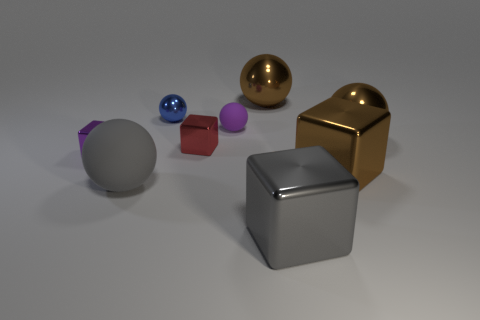Are there any other small red cubes made of the same material as the small red cube?
Your answer should be compact. No. There is a tiny purple metallic thing; what shape is it?
Your answer should be very brief. Cube. What is the shape of the large gray thing to the right of the brown metal thing left of the large brown metallic cube?
Provide a succinct answer. Cube. How many other things are the same shape as the small purple metal object?
Your answer should be compact. 3. There is a shiny sphere that is right of the brown metal thing that is behind the tiny blue thing; what size is it?
Provide a short and direct response. Large. Are there any large gray balls?
Give a very brief answer. Yes. There is a brown object that is behind the purple rubber sphere; how many large gray metal cubes are behind it?
Offer a very short reply. 0. There is a small thing left of the gray ball; what shape is it?
Offer a very short reply. Cube. What is the material of the big brown sphere that is on the right side of the gray object to the right of the brown shiny sphere to the left of the gray cube?
Provide a short and direct response. Metal. What number of other objects are the same size as the purple rubber object?
Offer a very short reply. 3. 